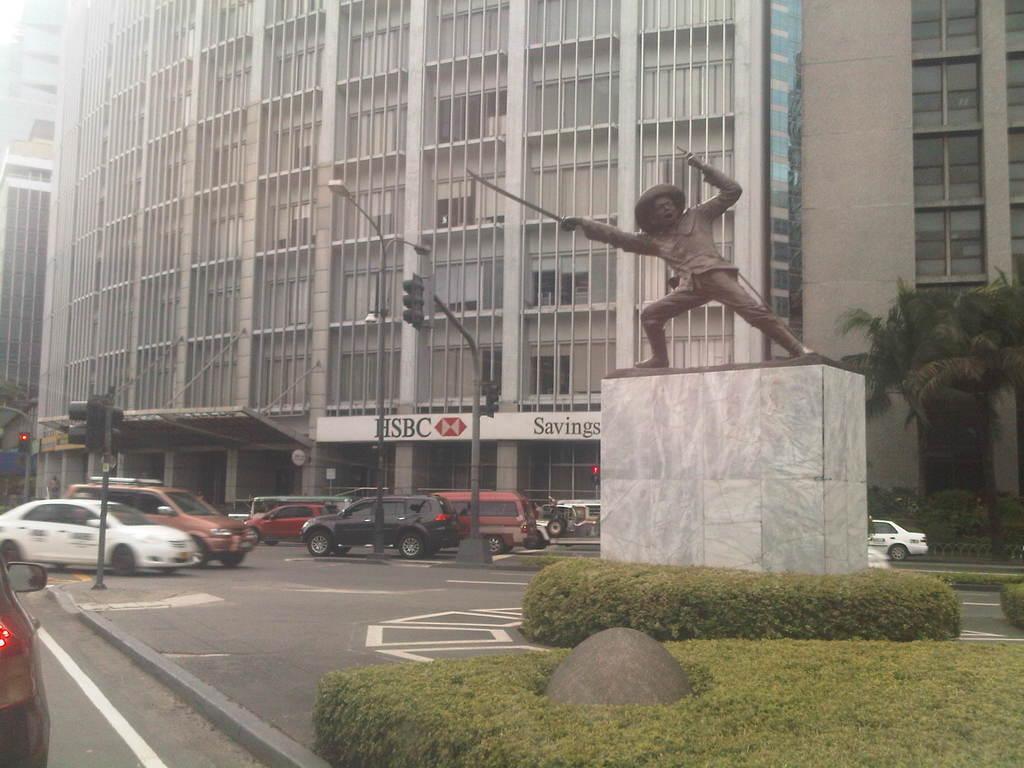In one or two sentences, can you explain what this image depicts? In this image we can see a person's status on a platform , plants, vehicles on the road, trees, buildings, windows and a name board on the wall. 